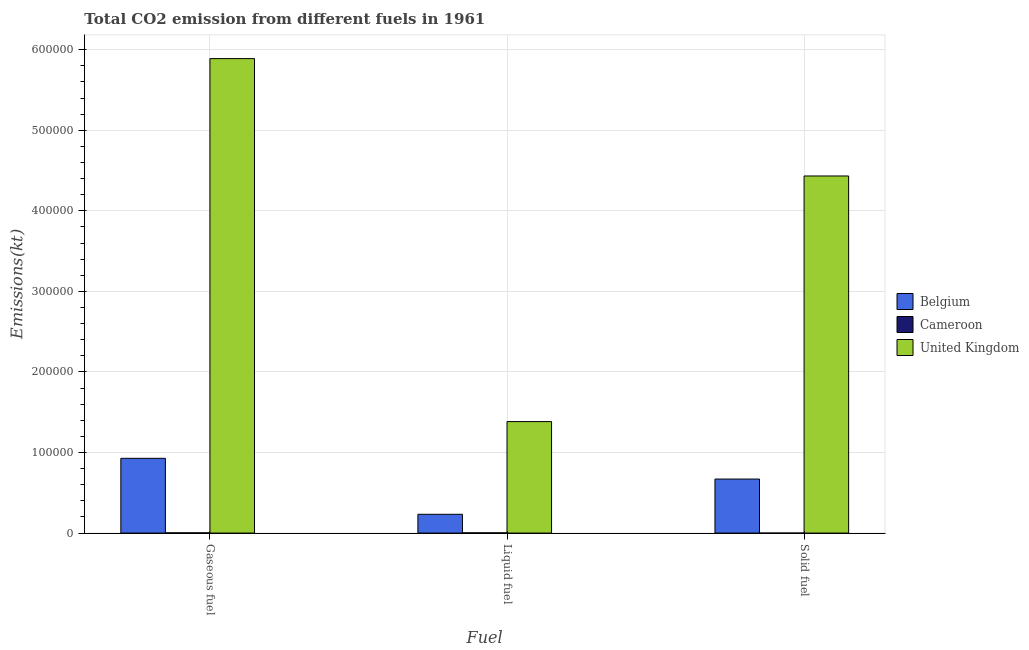How many groups of bars are there?
Your answer should be compact. 3. Are the number of bars on each tick of the X-axis equal?
Provide a succinct answer. Yes. How many bars are there on the 2nd tick from the left?
Make the answer very short. 3. What is the label of the 1st group of bars from the left?
Offer a very short reply. Gaseous fuel. What is the amount of co2 emissions from solid fuel in Belgium?
Provide a short and direct response. 6.70e+04. Across all countries, what is the maximum amount of co2 emissions from solid fuel?
Provide a succinct answer. 4.43e+05. Across all countries, what is the minimum amount of co2 emissions from gaseous fuel?
Your response must be concise. 282.36. In which country was the amount of co2 emissions from liquid fuel minimum?
Your response must be concise. Cameroon. What is the total amount of co2 emissions from gaseous fuel in the graph?
Offer a terse response. 6.82e+05. What is the difference between the amount of co2 emissions from gaseous fuel in Cameroon and that in United Kingdom?
Give a very brief answer. -5.89e+05. What is the difference between the amount of co2 emissions from solid fuel in Belgium and the amount of co2 emissions from gaseous fuel in United Kingdom?
Your response must be concise. -5.22e+05. What is the average amount of co2 emissions from liquid fuel per country?
Offer a terse response. 5.40e+04. What is the difference between the amount of co2 emissions from solid fuel and amount of co2 emissions from liquid fuel in Cameroon?
Ensure brevity in your answer.  -275.03. What is the ratio of the amount of co2 emissions from gaseous fuel in Belgium to that in United Kingdom?
Provide a short and direct response. 0.16. Is the amount of co2 emissions from gaseous fuel in United Kingdom less than that in Belgium?
Keep it short and to the point. No. Is the difference between the amount of co2 emissions from gaseous fuel in Belgium and Cameroon greater than the difference between the amount of co2 emissions from solid fuel in Belgium and Cameroon?
Provide a succinct answer. Yes. What is the difference between the highest and the second highest amount of co2 emissions from solid fuel?
Make the answer very short. 3.76e+05. What is the difference between the highest and the lowest amount of co2 emissions from solid fuel?
Offer a terse response. 4.43e+05. Is the sum of the amount of co2 emissions from solid fuel in United Kingdom and Cameroon greater than the maximum amount of co2 emissions from gaseous fuel across all countries?
Keep it short and to the point. No. Are all the bars in the graph horizontal?
Your answer should be very brief. No. Are the values on the major ticks of Y-axis written in scientific E-notation?
Your answer should be compact. No. What is the title of the graph?
Your response must be concise. Total CO2 emission from different fuels in 1961. Does "Iceland" appear as one of the legend labels in the graph?
Provide a succinct answer. No. What is the label or title of the X-axis?
Your answer should be compact. Fuel. What is the label or title of the Y-axis?
Offer a very short reply. Emissions(kt). What is the Emissions(kt) in Belgium in Gaseous fuel?
Ensure brevity in your answer.  9.28e+04. What is the Emissions(kt) in Cameroon in Gaseous fuel?
Keep it short and to the point. 282.36. What is the Emissions(kt) of United Kingdom in Gaseous fuel?
Offer a terse response. 5.89e+05. What is the Emissions(kt) of Belgium in Liquid fuel?
Give a very brief answer. 2.33e+04. What is the Emissions(kt) in Cameroon in Liquid fuel?
Provide a short and direct response. 278.69. What is the Emissions(kt) in United Kingdom in Liquid fuel?
Make the answer very short. 1.38e+05. What is the Emissions(kt) in Belgium in Solid fuel?
Offer a terse response. 6.70e+04. What is the Emissions(kt) of Cameroon in Solid fuel?
Offer a terse response. 3.67. What is the Emissions(kt) of United Kingdom in Solid fuel?
Offer a very short reply. 4.43e+05. Across all Fuel, what is the maximum Emissions(kt) of Belgium?
Your response must be concise. 9.28e+04. Across all Fuel, what is the maximum Emissions(kt) in Cameroon?
Your response must be concise. 282.36. Across all Fuel, what is the maximum Emissions(kt) in United Kingdom?
Offer a terse response. 5.89e+05. Across all Fuel, what is the minimum Emissions(kt) of Belgium?
Keep it short and to the point. 2.33e+04. Across all Fuel, what is the minimum Emissions(kt) in Cameroon?
Offer a very short reply. 3.67. Across all Fuel, what is the minimum Emissions(kt) in United Kingdom?
Your answer should be very brief. 1.38e+05. What is the total Emissions(kt) in Belgium in the graph?
Offer a terse response. 1.83e+05. What is the total Emissions(kt) of Cameroon in the graph?
Make the answer very short. 564.72. What is the total Emissions(kt) in United Kingdom in the graph?
Your response must be concise. 1.17e+06. What is the difference between the Emissions(kt) of Belgium in Gaseous fuel and that in Liquid fuel?
Provide a succinct answer. 6.95e+04. What is the difference between the Emissions(kt) of Cameroon in Gaseous fuel and that in Liquid fuel?
Keep it short and to the point. 3.67. What is the difference between the Emissions(kt) in United Kingdom in Gaseous fuel and that in Liquid fuel?
Offer a very short reply. 4.51e+05. What is the difference between the Emissions(kt) of Belgium in Gaseous fuel and that in Solid fuel?
Make the answer very short. 2.57e+04. What is the difference between the Emissions(kt) in Cameroon in Gaseous fuel and that in Solid fuel?
Your response must be concise. 278.69. What is the difference between the Emissions(kt) of United Kingdom in Gaseous fuel and that in Solid fuel?
Your answer should be compact. 1.46e+05. What is the difference between the Emissions(kt) of Belgium in Liquid fuel and that in Solid fuel?
Give a very brief answer. -4.37e+04. What is the difference between the Emissions(kt) in Cameroon in Liquid fuel and that in Solid fuel?
Give a very brief answer. 275.02. What is the difference between the Emissions(kt) in United Kingdom in Liquid fuel and that in Solid fuel?
Ensure brevity in your answer.  -3.05e+05. What is the difference between the Emissions(kt) of Belgium in Gaseous fuel and the Emissions(kt) of Cameroon in Liquid fuel?
Keep it short and to the point. 9.25e+04. What is the difference between the Emissions(kt) in Belgium in Gaseous fuel and the Emissions(kt) in United Kingdom in Liquid fuel?
Your response must be concise. -4.56e+04. What is the difference between the Emissions(kt) in Cameroon in Gaseous fuel and the Emissions(kt) in United Kingdom in Liquid fuel?
Ensure brevity in your answer.  -1.38e+05. What is the difference between the Emissions(kt) of Belgium in Gaseous fuel and the Emissions(kt) of Cameroon in Solid fuel?
Your response must be concise. 9.28e+04. What is the difference between the Emissions(kt) in Belgium in Gaseous fuel and the Emissions(kt) in United Kingdom in Solid fuel?
Provide a short and direct response. -3.50e+05. What is the difference between the Emissions(kt) in Cameroon in Gaseous fuel and the Emissions(kt) in United Kingdom in Solid fuel?
Your response must be concise. -4.43e+05. What is the difference between the Emissions(kt) of Belgium in Liquid fuel and the Emissions(kt) of Cameroon in Solid fuel?
Provide a succinct answer. 2.33e+04. What is the difference between the Emissions(kt) of Belgium in Liquid fuel and the Emissions(kt) of United Kingdom in Solid fuel?
Offer a very short reply. -4.20e+05. What is the difference between the Emissions(kt) in Cameroon in Liquid fuel and the Emissions(kt) in United Kingdom in Solid fuel?
Your answer should be compact. -4.43e+05. What is the average Emissions(kt) of Belgium per Fuel?
Your answer should be very brief. 6.10e+04. What is the average Emissions(kt) in Cameroon per Fuel?
Keep it short and to the point. 188.24. What is the average Emissions(kt) in United Kingdom per Fuel?
Your answer should be compact. 3.90e+05. What is the difference between the Emissions(kt) in Belgium and Emissions(kt) in Cameroon in Gaseous fuel?
Your answer should be compact. 9.25e+04. What is the difference between the Emissions(kt) of Belgium and Emissions(kt) of United Kingdom in Gaseous fuel?
Provide a succinct answer. -4.96e+05. What is the difference between the Emissions(kt) of Cameroon and Emissions(kt) of United Kingdom in Gaseous fuel?
Give a very brief answer. -5.89e+05. What is the difference between the Emissions(kt) of Belgium and Emissions(kt) of Cameroon in Liquid fuel?
Offer a terse response. 2.30e+04. What is the difference between the Emissions(kt) of Belgium and Emissions(kt) of United Kingdom in Liquid fuel?
Make the answer very short. -1.15e+05. What is the difference between the Emissions(kt) of Cameroon and Emissions(kt) of United Kingdom in Liquid fuel?
Offer a terse response. -1.38e+05. What is the difference between the Emissions(kt) in Belgium and Emissions(kt) in Cameroon in Solid fuel?
Make the answer very short. 6.70e+04. What is the difference between the Emissions(kt) of Belgium and Emissions(kt) of United Kingdom in Solid fuel?
Make the answer very short. -3.76e+05. What is the difference between the Emissions(kt) of Cameroon and Emissions(kt) of United Kingdom in Solid fuel?
Your response must be concise. -4.43e+05. What is the ratio of the Emissions(kt) of Belgium in Gaseous fuel to that in Liquid fuel?
Offer a terse response. 3.98. What is the ratio of the Emissions(kt) of Cameroon in Gaseous fuel to that in Liquid fuel?
Offer a very short reply. 1.01. What is the ratio of the Emissions(kt) in United Kingdom in Gaseous fuel to that in Liquid fuel?
Keep it short and to the point. 4.26. What is the ratio of the Emissions(kt) in Belgium in Gaseous fuel to that in Solid fuel?
Give a very brief answer. 1.38. What is the ratio of the Emissions(kt) of United Kingdom in Gaseous fuel to that in Solid fuel?
Offer a very short reply. 1.33. What is the ratio of the Emissions(kt) in Belgium in Liquid fuel to that in Solid fuel?
Provide a succinct answer. 0.35. What is the ratio of the Emissions(kt) of United Kingdom in Liquid fuel to that in Solid fuel?
Provide a short and direct response. 0.31. What is the difference between the highest and the second highest Emissions(kt) of Belgium?
Provide a succinct answer. 2.57e+04. What is the difference between the highest and the second highest Emissions(kt) of Cameroon?
Your answer should be compact. 3.67. What is the difference between the highest and the second highest Emissions(kt) in United Kingdom?
Offer a terse response. 1.46e+05. What is the difference between the highest and the lowest Emissions(kt) of Belgium?
Your response must be concise. 6.95e+04. What is the difference between the highest and the lowest Emissions(kt) of Cameroon?
Your response must be concise. 278.69. What is the difference between the highest and the lowest Emissions(kt) of United Kingdom?
Offer a very short reply. 4.51e+05. 